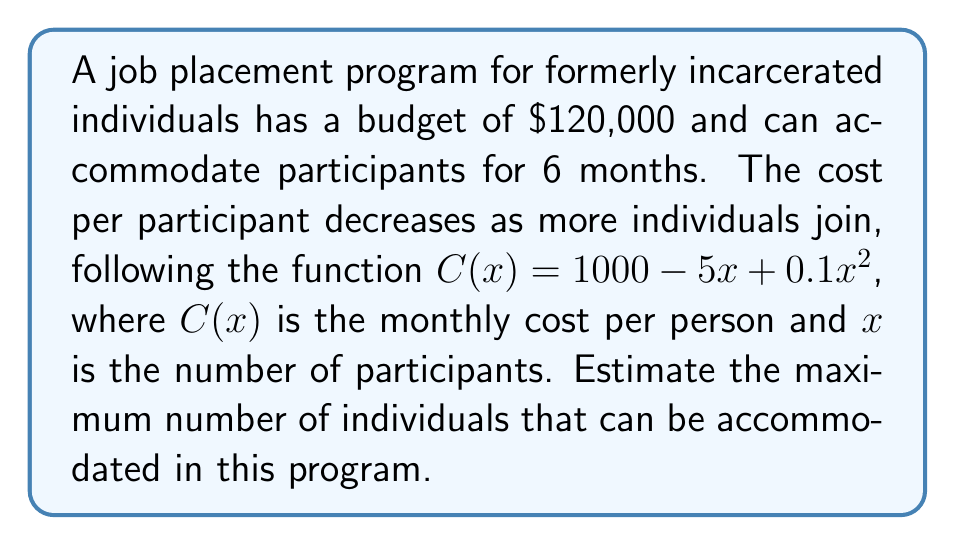What is the answer to this math problem? 1) First, we need to set up an inequality that represents the total cost being less than or equal to the budget:

   $6x(1000 - 5x + 0.1x^2) \leq 120000$

2) Expand the left side of the inequality:
   
   $6000x - 30x^2 + 0.6x^3 \leq 120000$

3) Rearrange to standard form:

   $0.6x^3 - 30x^2 + 6000x - 120000 \leq 0$

4) This is a cubic inequality. To solve it, we need to find the roots of the corresponding equation:

   $0.6x^3 - 30x^2 + 6000x - 120000 = 0$

5) This equation is difficult to solve analytically. We can use numerical methods or graphing to estimate the solution.

6) Using a graphing calculator or computer software, we can see that the curve intersects the x-axis at approximately $x = 20.7$.

7) Since we need the maximum number of whole individuals, we round down to 20.

8) To verify, we can check if 20 satisfies the original inequality:

   $6 \cdot 20 \cdot (1000 - 5 \cdot 20 + 0.1 \cdot 20^2) = 117600 \leq 120000$

   $6 \cdot 21 \cdot (1000 - 5 \cdot 21 + 0.1 \cdot 21^2) = 124902 > 120000$

9) Therefore, the maximum number of individuals that can be accommodated is 20.
Answer: 20 individuals 